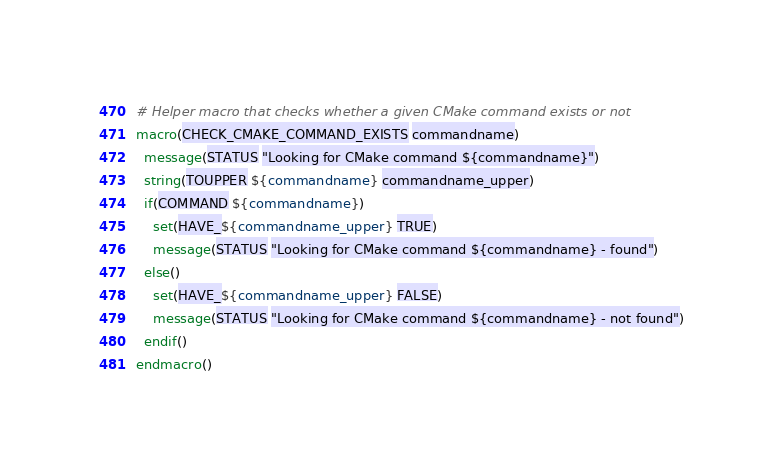<code> <loc_0><loc_0><loc_500><loc_500><_CMake_># Helper macro that checks whether a given CMake command exists or not
macro(CHECK_CMAKE_COMMAND_EXISTS commandname)
  message(STATUS "Looking for CMake command ${commandname}")
  string(TOUPPER ${commandname} commandname_upper)
  if(COMMAND ${commandname})
    set(HAVE_${commandname_upper} TRUE)
    message(STATUS "Looking for CMake command ${commandname} - found")
  else()
    set(HAVE_${commandname_upper} FALSE)
    message(STATUS "Looking for CMake command ${commandname} - not found")
  endif()
endmacro()
</code> 